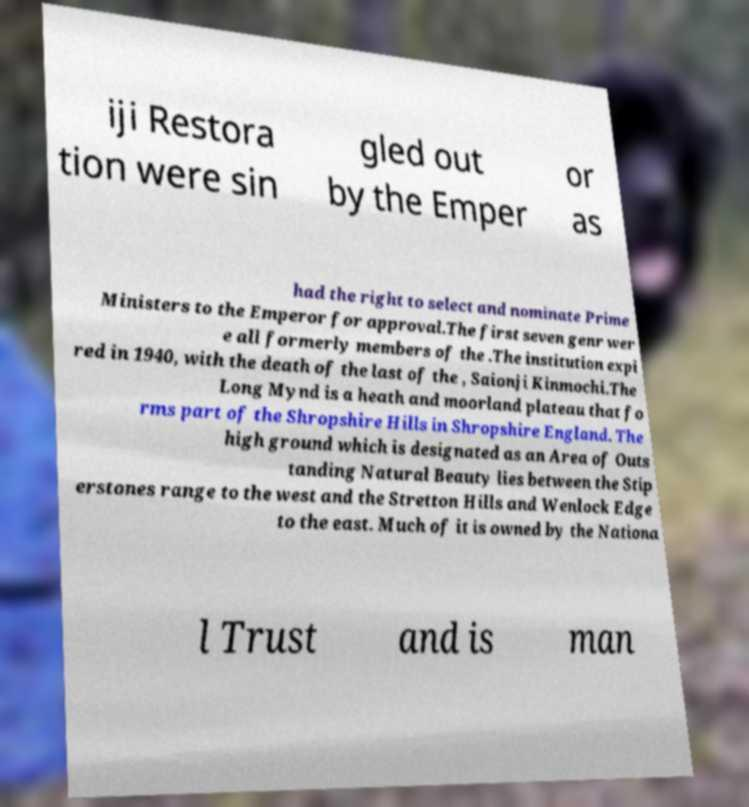Could you assist in decoding the text presented in this image and type it out clearly? iji Restora tion were sin gled out by the Emper or as had the right to select and nominate Prime Ministers to the Emperor for approval.The first seven genr wer e all formerly members of the .The institution expi red in 1940, with the death of the last of the , Saionji Kinmochi.The Long Mynd is a heath and moorland plateau that fo rms part of the Shropshire Hills in Shropshire England. The high ground which is designated as an Area of Outs tanding Natural Beauty lies between the Stip erstones range to the west and the Stretton Hills and Wenlock Edge to the east. Much of it is owned by the Nationa l Trust and is man 